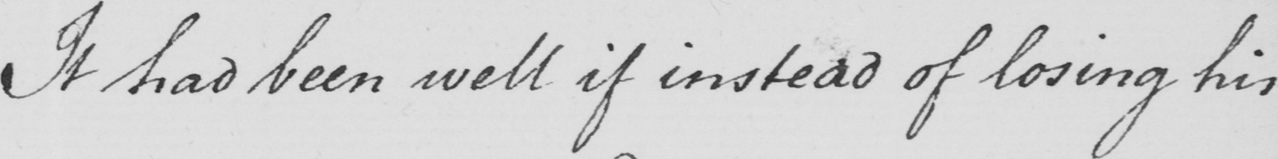What does this handwritten line say? It had been well if instead of losing his 